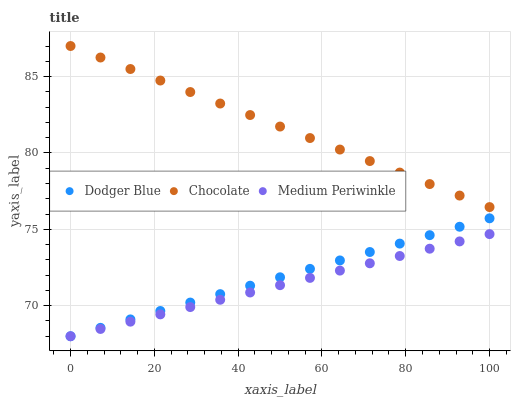Does Medium Periwinkle have the minimum area under the curve?
Answer yes or no. Yes. Does Chocolate have the maximum area under the curve?
Answer yes or no. Yes. Does Dodger Blue have the minimum area under the curve?
Answer yes or no. No. Does Dodger Blue have the maximum area under the curve?
Answer yes or no. No. Is Medium Periwinkle the smoothest?
Answer yes or no. Yes. Is Dodger Blue the roughest?
Answer yes or no. Yes. Is Chocolate the smoothest?
Answer yes or no. No. Is Chocolate the roughest?
Answer yes or no. No. Does Medium Periwinkle have the lowest value?
Answer yes or no. Yes. Does Chocolate have the lowest value?
Answer yes or no. No. Does Chocolate have the highest value?
Answer yes or no. Yes. Does Dodger Blue have the highest value?
Answer yes or no. No. Is Medium Periwinkle less than Chocolate?
Answer yes or no. Yes. Is Chocolate greater than Dodger Blue?
Answer yes or no. Yes. Does Dodger Blue intersect Medium Periwinkle?
Answer yes or no. Yes. Is Dodger Blue less than Medium Periwinkle?
Answer yes or no. No. Is Dodger Blue greater than Medium Periwinkle?
Answer yes or no. No. Does Medium Periwinkle intersect Chocolate?
Answer yes or no. No. 